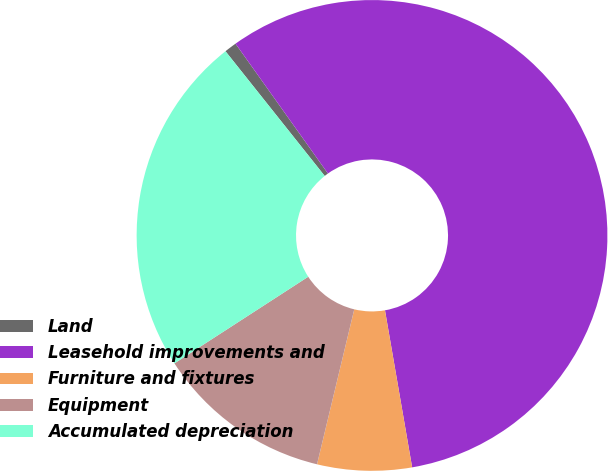Convert chart to OTSL. <chart><loc_0><loc_0><loc_500><loc_500><pie_chart><fcel>Land<fcel>Leasehold improvements and<fcel>Furniture and fixtures<fcel>Equipment<fcel>Accumulated depreciation<nl><fcel>0.85%<fcel>57.12%<fcel>6.48%<fcel>12.1%<fcel>23.45%<nl></chart> 